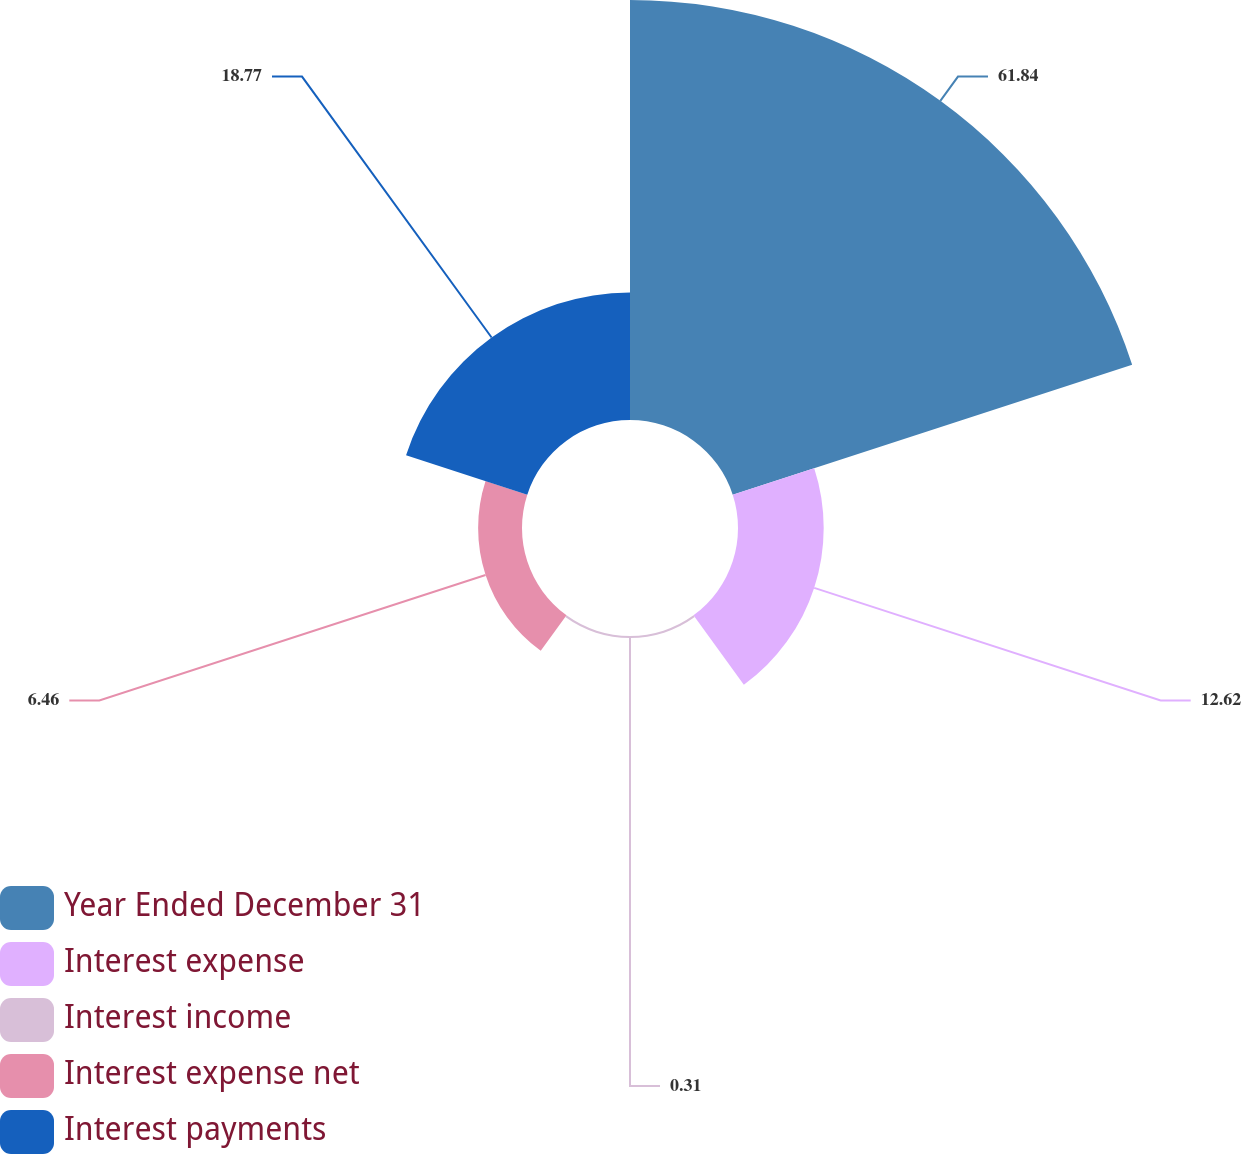<chart> <loc_0><loc_0><loc_500><loc_500><pie_chart><fcel>Year Ended December 31<fcel>Interest expense<fcel>Interest income<fcel>Interest expense net<fcel>Interest payments<nl><fcel>61.85%<fcel>12.62%<fcel>0.31%<fcel>6.46%<fcel>18.77%<nl></chart> 